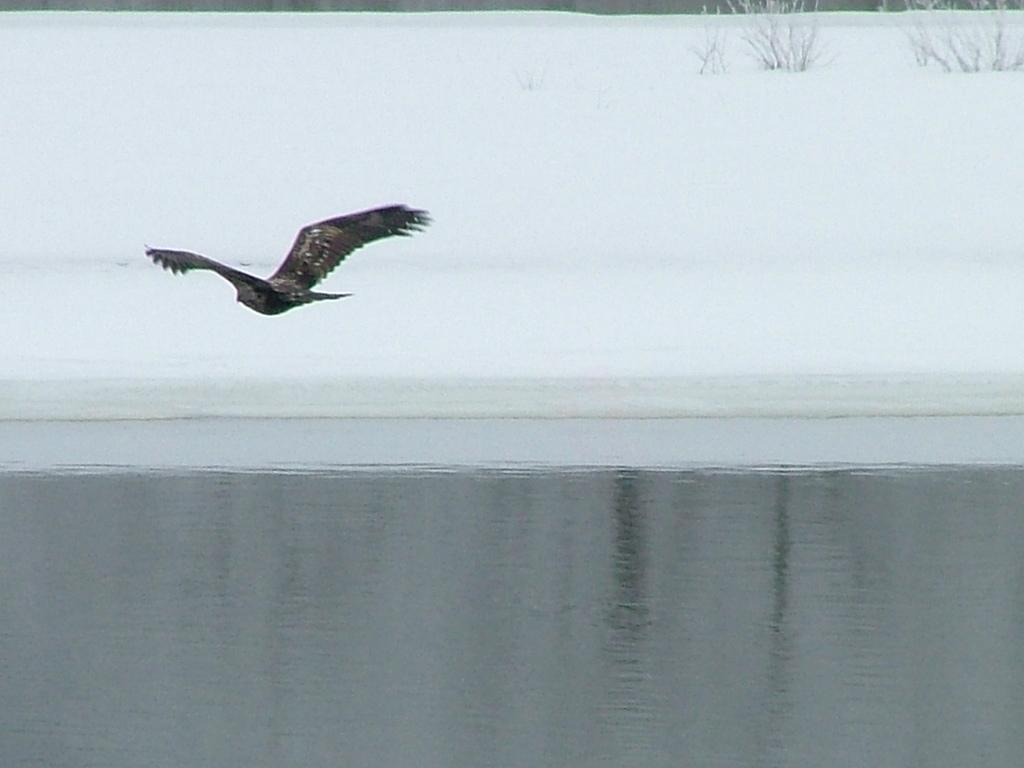How would you summarize this image in a sentence or two? In the image there is a bird flying in the air and in the back the land is covered with snow all over it. there are some plants on the right side and in the front it's a lake. 